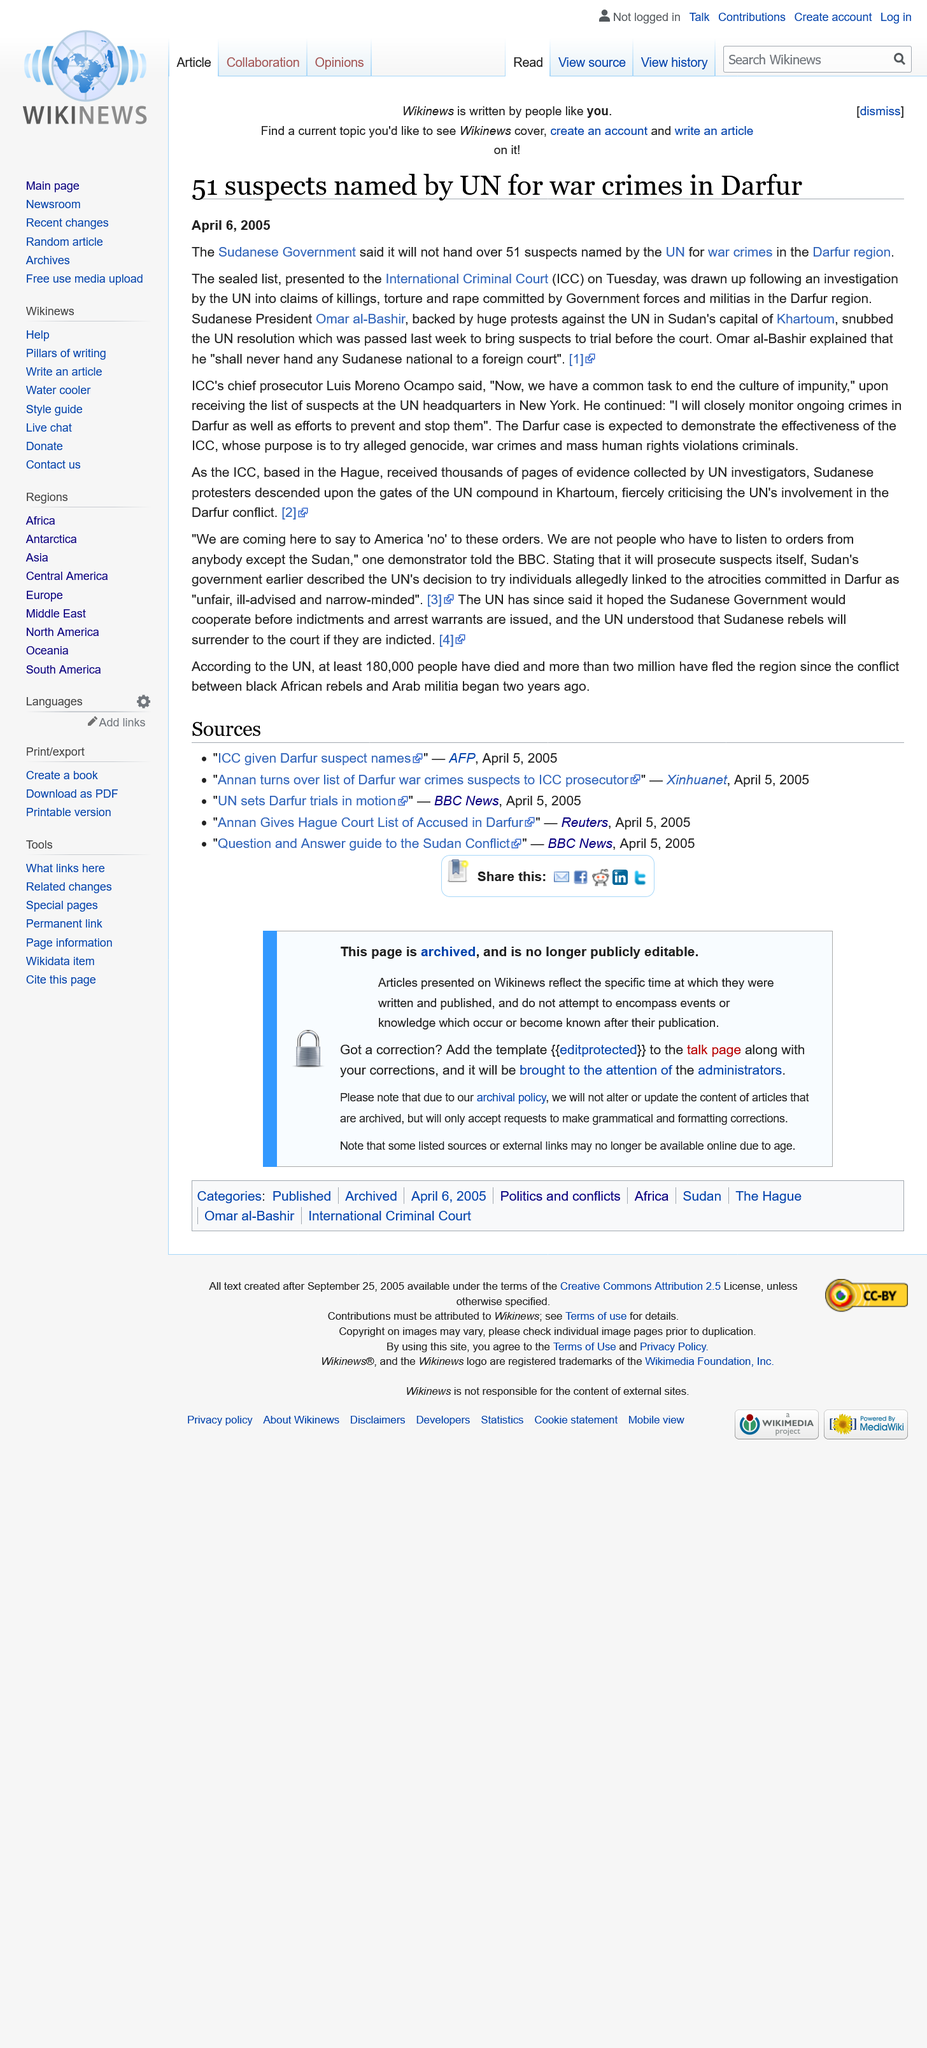Highlight a few significant elements in this photo. The International Criminal Court, commonly referred to as ICC, is an international organization established to prosecute individuals for crimes against humanity, genocide, and war crimes. The fact that the list of 51 suspects named by the UN for war crimes is a sealed list has been confirmed. The International Criminal Court (ICC) is headquartered in The Hague, the Netherlands. 